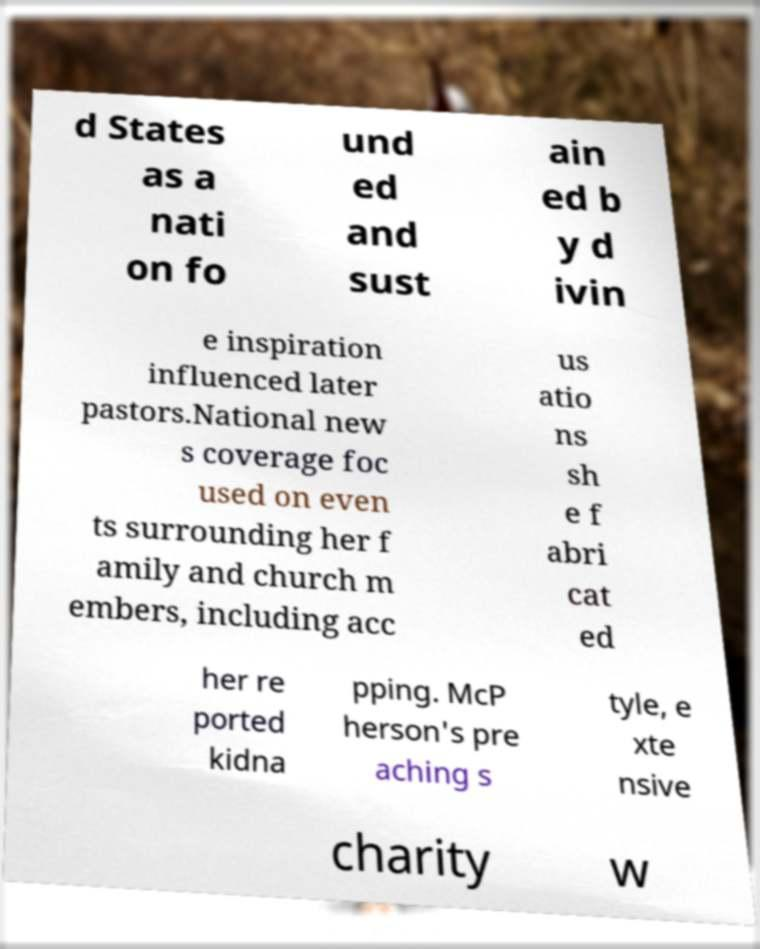Please read and relay the text visible in this image. What does it say? d States as a nati on fo und ed and sust ain ed b y d ivin e inspiration influenced later pastors.National new s coverage foc used on even ts surrounding her f amily and church m embers, including acc us atio ns sh e f abri cat ed her re ported kidna pping. McP herson's pre aching s tyle, e xte nsive charity w 